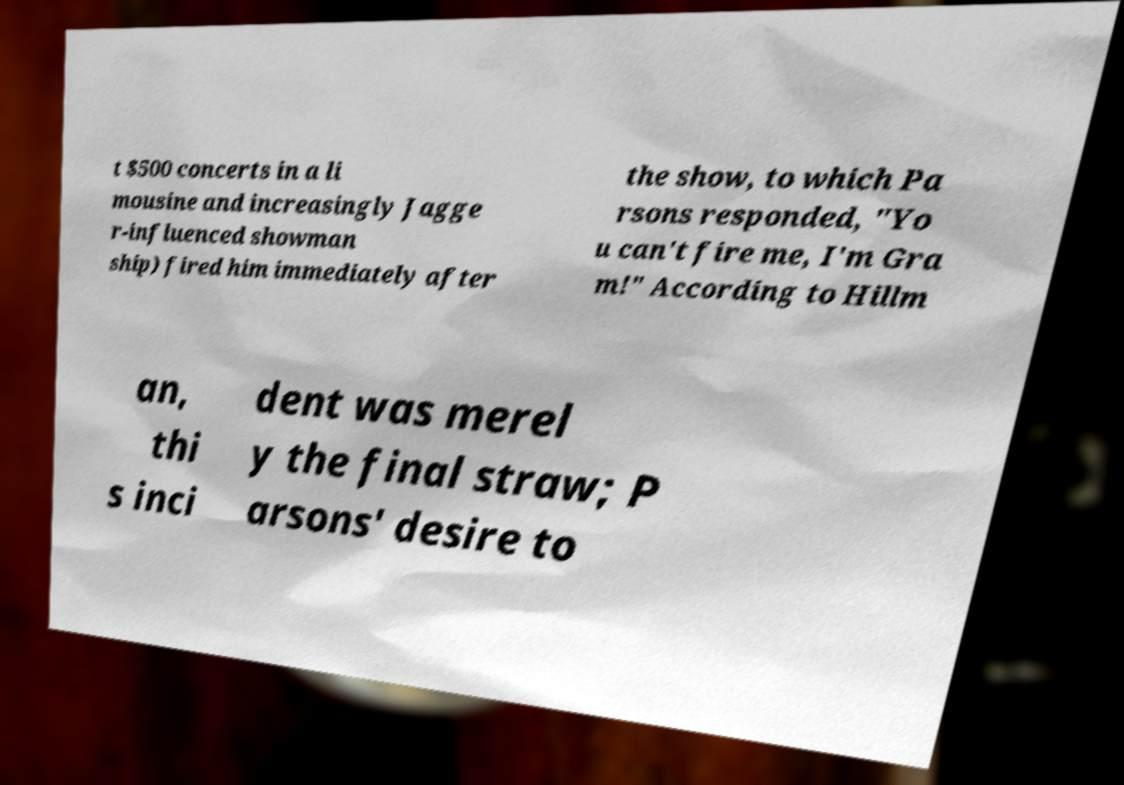Could you assist in decoding the text presented in this image and type it out clearly? t $500 concerts in a li mousine and increasingly Jagge r-influenced showman ship) fired him immediately after the show, to which Pa rsons responded, "Yo u can't fire me, I'm Gra m!" According to Hillm an, thi s inci dent was merel y the final straw; P arsons' desire to 